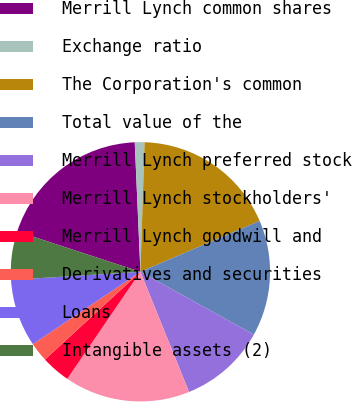<chart> <loc_0><loc_0><loc_500><loc_500><pie_chart><fcel>Merrill Lynch common shares<fcel>Exchange ratio<fcel>The Corporation's common<fcel>Total value of the<fcel>Merrill Lynch preferred stock<fcel>Merrill Lynch stockholders'<fcel>Merrill Lynch goodwill and<fcel>Derivatives and securities<fcel>Loans<fcel>Intangible assets (2)<nl><fcel>19.27%<fcel>1.21%<fcel>18.07%<fcel>14.46%<fcel>10.84%<fcel>15.66%<fcel>3.62%<fcel>2.41%<fcel>8.43%<fcel>6.03%<nl></chart> 